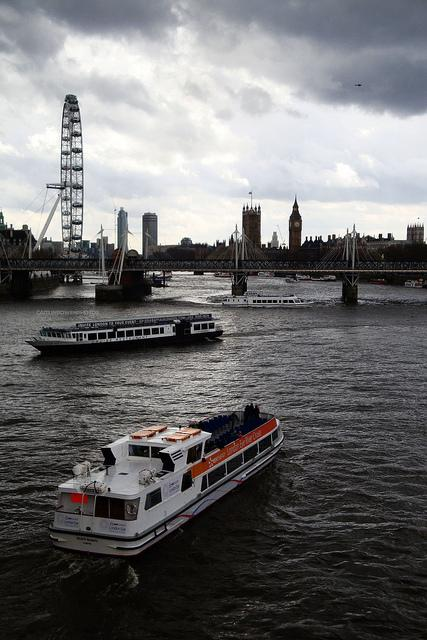What problem will the people on the ferry face? Please explain your reasoning. raining. The problem is rain. 